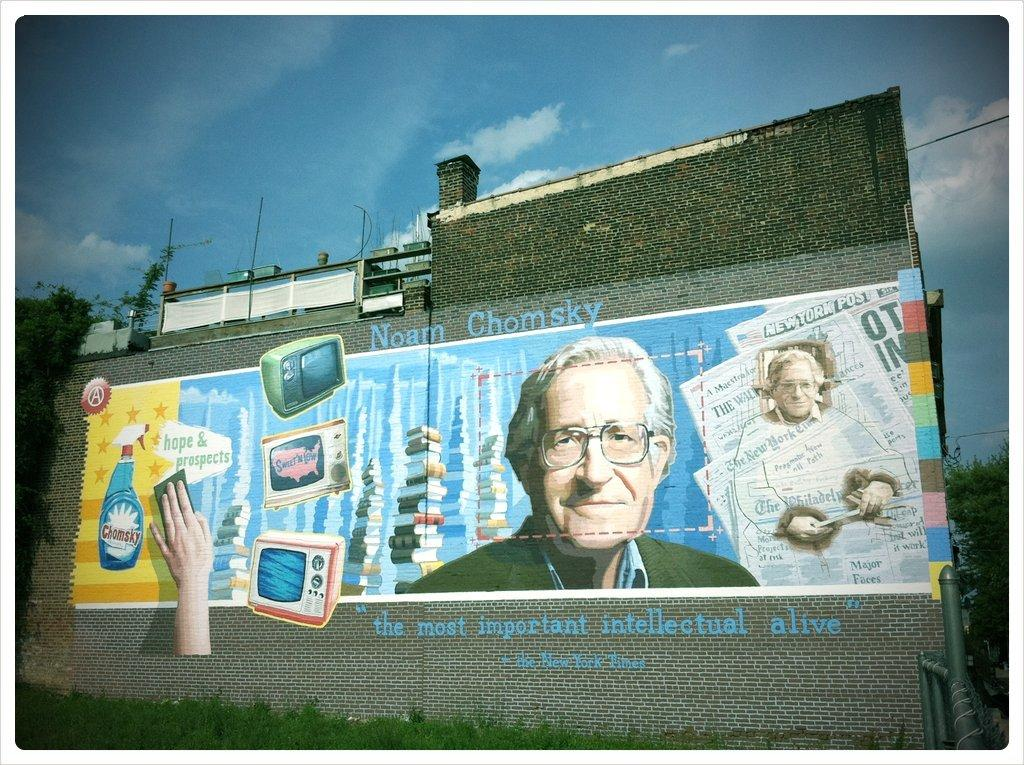Provide a one-sentence caption for the provided image. Drawing on a wall showing a man's face and the name "Noam Chomsky" on top. 